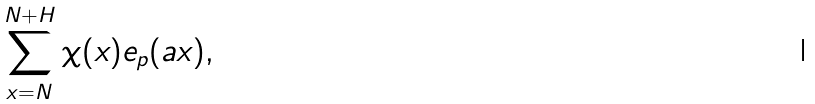Convert formula to latex. <formula><loc_0><loc_0><loc_500><loc_500>\sum _ { x = N } ^ { N + H } \chi ( x ) e _ { p } ( a x ) ,</formula> 